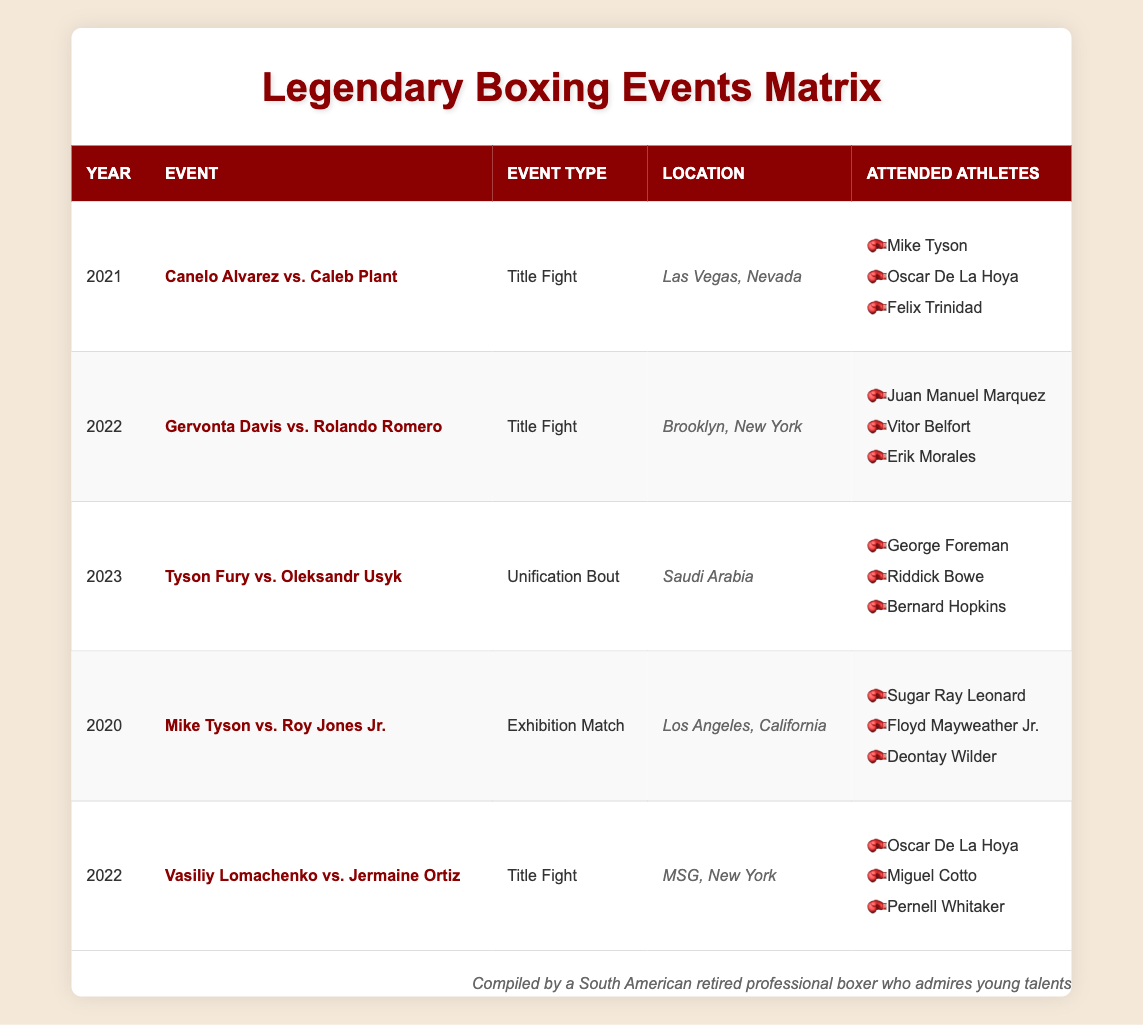What was the location of the 2022 Title Fight between Gervonta Davis and Rolando Romero? In the table, we can find the event listed under the year 2022, specifically the Title Fight between Gervonta Davis and Rolando Romero. The corresponding location for this event is mentioned as Brooklyn, New York.
Answer: Brooklyn, New York Which retired athlete attended the 2021 event featuring Canelo Alvarez? Referring to the table, we can find that in 2021, Canelo Alvarez faced Caleb Plant. Among the attending athletes listed, we see Mike Tyson, Oscar De La Hoya, and Felix Trinidad. Any of these names would be correct.
Answer: Mike Tyson, Oscar De La Hoya, or Felix Trinidad How many Title Fights took place in 2022? Looking at the table, we can identify events categorized as Title Fights. In 2022, there are two Title Fights mentioned: Gervonta Davis vs. Rolando Romero and Vasiliy Lomachenko vs. Jermaine Ortiz. Therefore, we count two events.
Answer: 2 Did George Foreman attend the 2023 Tyson Fury event? From the table, under the 2023 row, we see the event Tyson Fury vs. Oleksandr Usyk listed. The attended athlete for this event includes George Foreman, confirming his attendance.
Answer: Yes Which event had the most retired athletes in attendance? By examining the number of attendees for each event, we can see in 2021 there were three athletes (Canelo Alvarez vs. Caleb Plant), in 2022 two events both had three attendees (Gervonta Davis vs. Rolando Romero and Lomachenko vs. Ortiz), and in 2023 three attendees (Tyson Fury vs. Usyk). All these events had the same number, so no single event had more attendees than others.
Answer: All had three attendees What type of event was Mike Tyson vs. Roy Jones Jr. in 2020? Referring to the 2020 row in the table, the event Mike Tyson vs. Roy Jones Jr. is categorized as an Exhibition Match.
Answer: Exhibition Match How many unique retired athletes attended events in 2022? In 2022, from the two events, attendees include Juan Manuel Marquez, Vitor Belfort, and Erik Morales for the Gervonta Davis event, and Oscar De La Hoya, Miguel Cotto, and Pernell Whitaker for the Lomachenko event. Adding them together gives us a total of six unique attendees.
Answer: 6 Was the location of the 2023 event in a country name? The location of the event in 2023 shows "Saudi Arabia," which is indeed a country name. Thus, this statement is true.
Answer: Yes Which event had the youngest retired athlete in attendance? Looking at the retired athletes from the listed events, it can be difficult to determine exact ages without further data. However, from the notable younger athletes, Vitor Belfort (attended in 2022) is generally recognized as younger than others like George Foreman or Mike Tyson. So, the Gervonta Davis event could be the answer based on the attendance of Vitor Belfort.
Answer: Gervonta Davis vs. Rolando Romero 